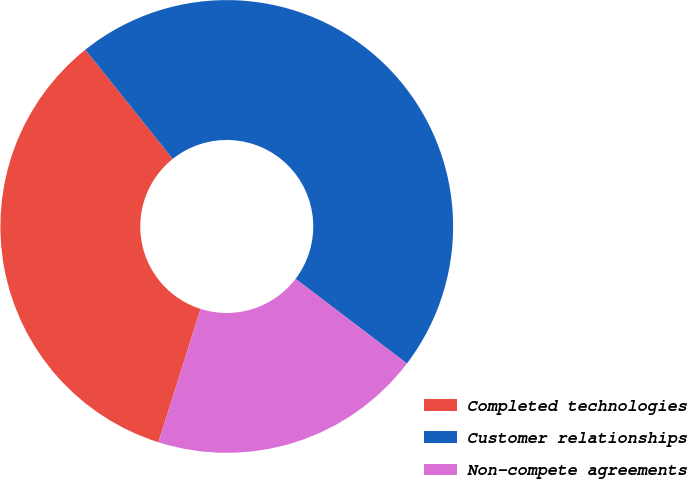<chart> <loc_0><loc_0><loc_500><loc_500><pie_chart><fcel>Completed technologies<fcel>Customer relationships<fcel>Non-compete agreements<nl><fcel>34.38%<fcel>46.09%<fcel>19.53%<nl></chart> 